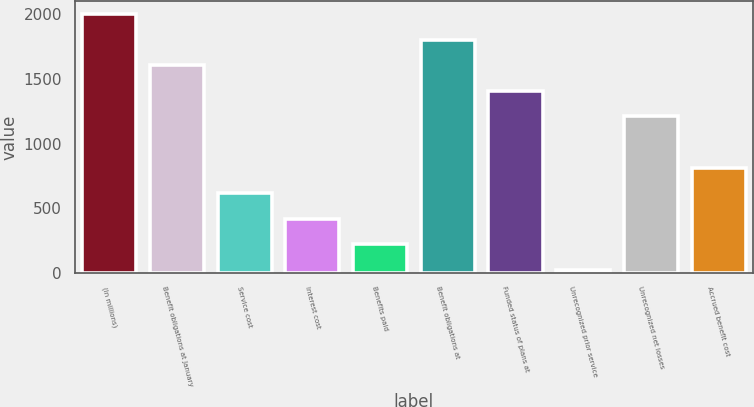<chart> <loc_0><loc_0><loc_500><loc_500><bar_chart><fcel>(In millions)<fcel>Benefit obligations at January<fcel>Service cost<fcel>Interest cost<fcel>Benefits paid<fcel>Benefit obligations at<fcel>Funded status of plans at<fcel>Unrecognized prior service<fcel>Unrecognized net losses<fcel>Accrued benefit cost<nl><fcel>2003<fcel>1606.6<fcel>615.6<fcel>417.4<fcel>219.2<fcel>1804.8<fcel>1408.4<fcel>21<fcel>1210.2<fcel>813.8<nl></chart> 